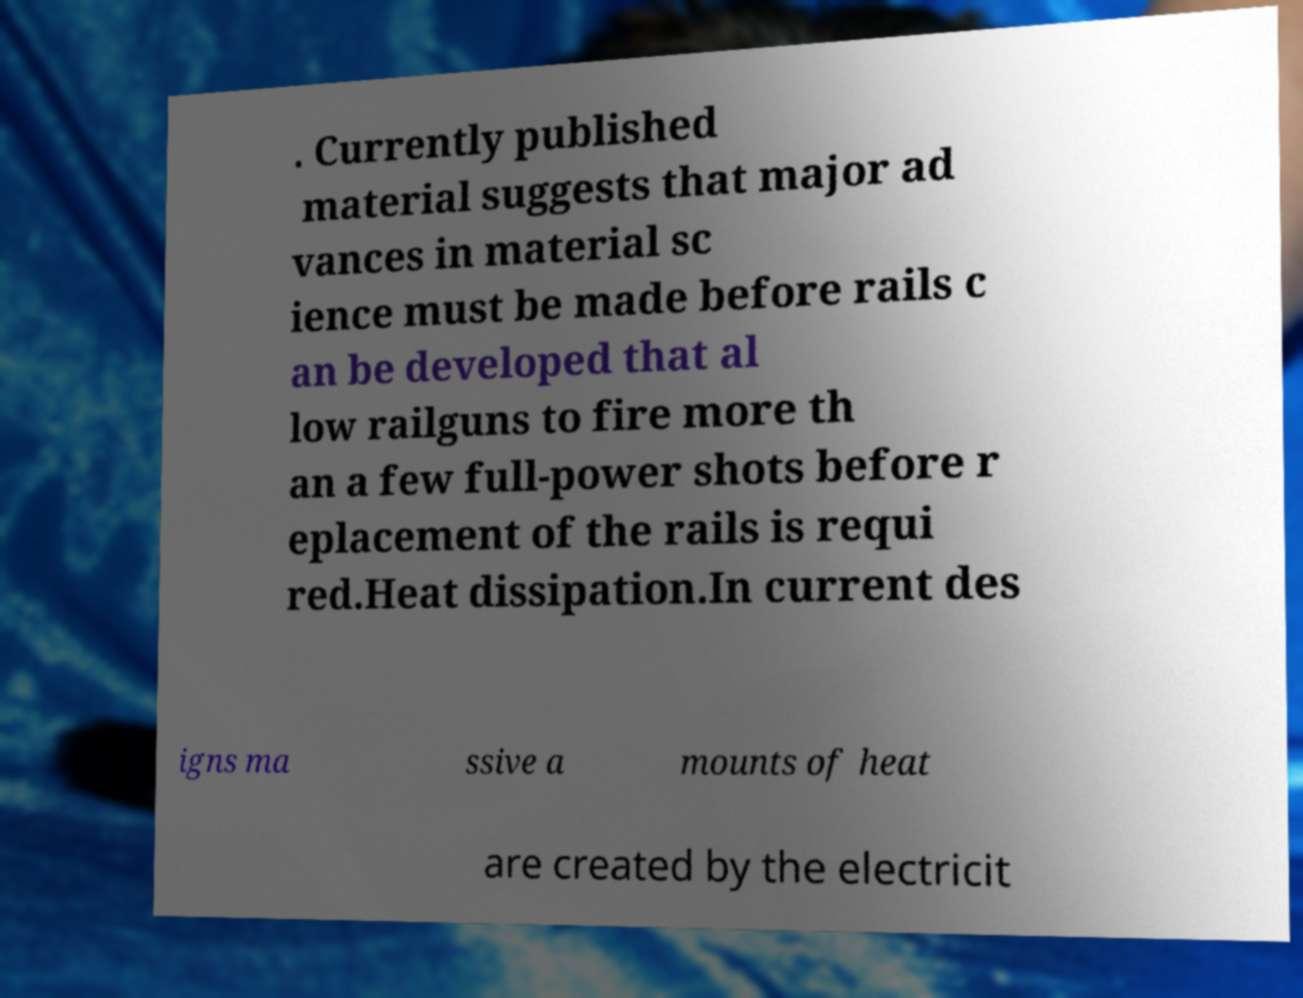Please identify and transcribe the text found in this image. . Currently published material suggests that major ad vances in material sc ience must be made before rails c an be developed that al low railguns to fire more th an a few full-power shots before r eplacement of the rails is requi red.Heat dissipation.In current des igns ma ssive a mounts of heat are created by the electricit 